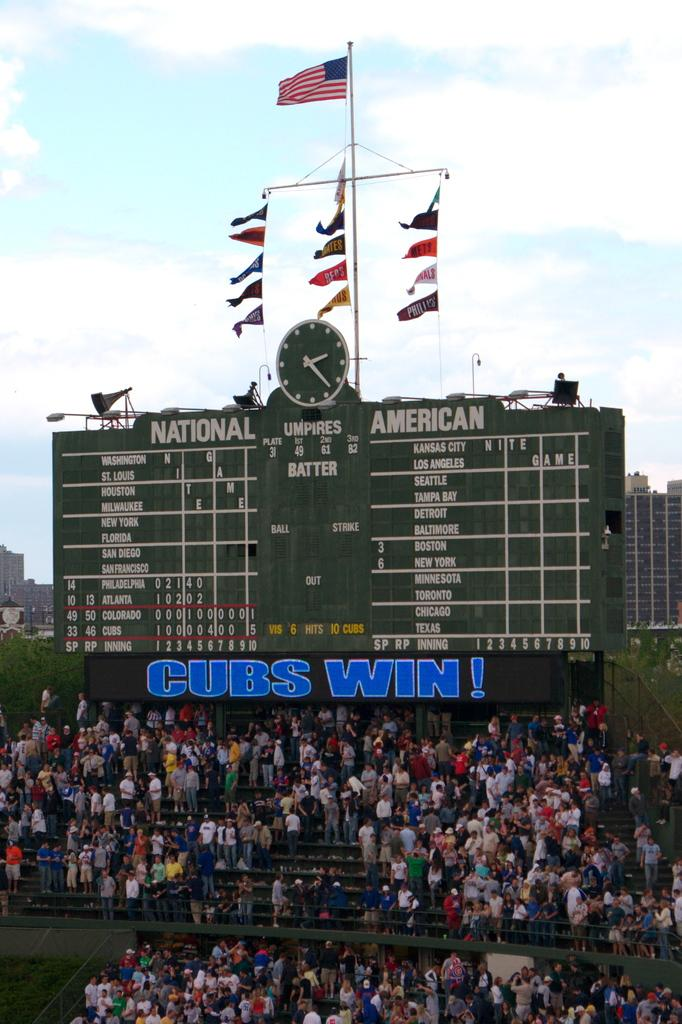<image>
Create a compact narrative representing the image presented. A baseball stadium is full of fans with a large Cubs Win sign underneath the scoreboard. 